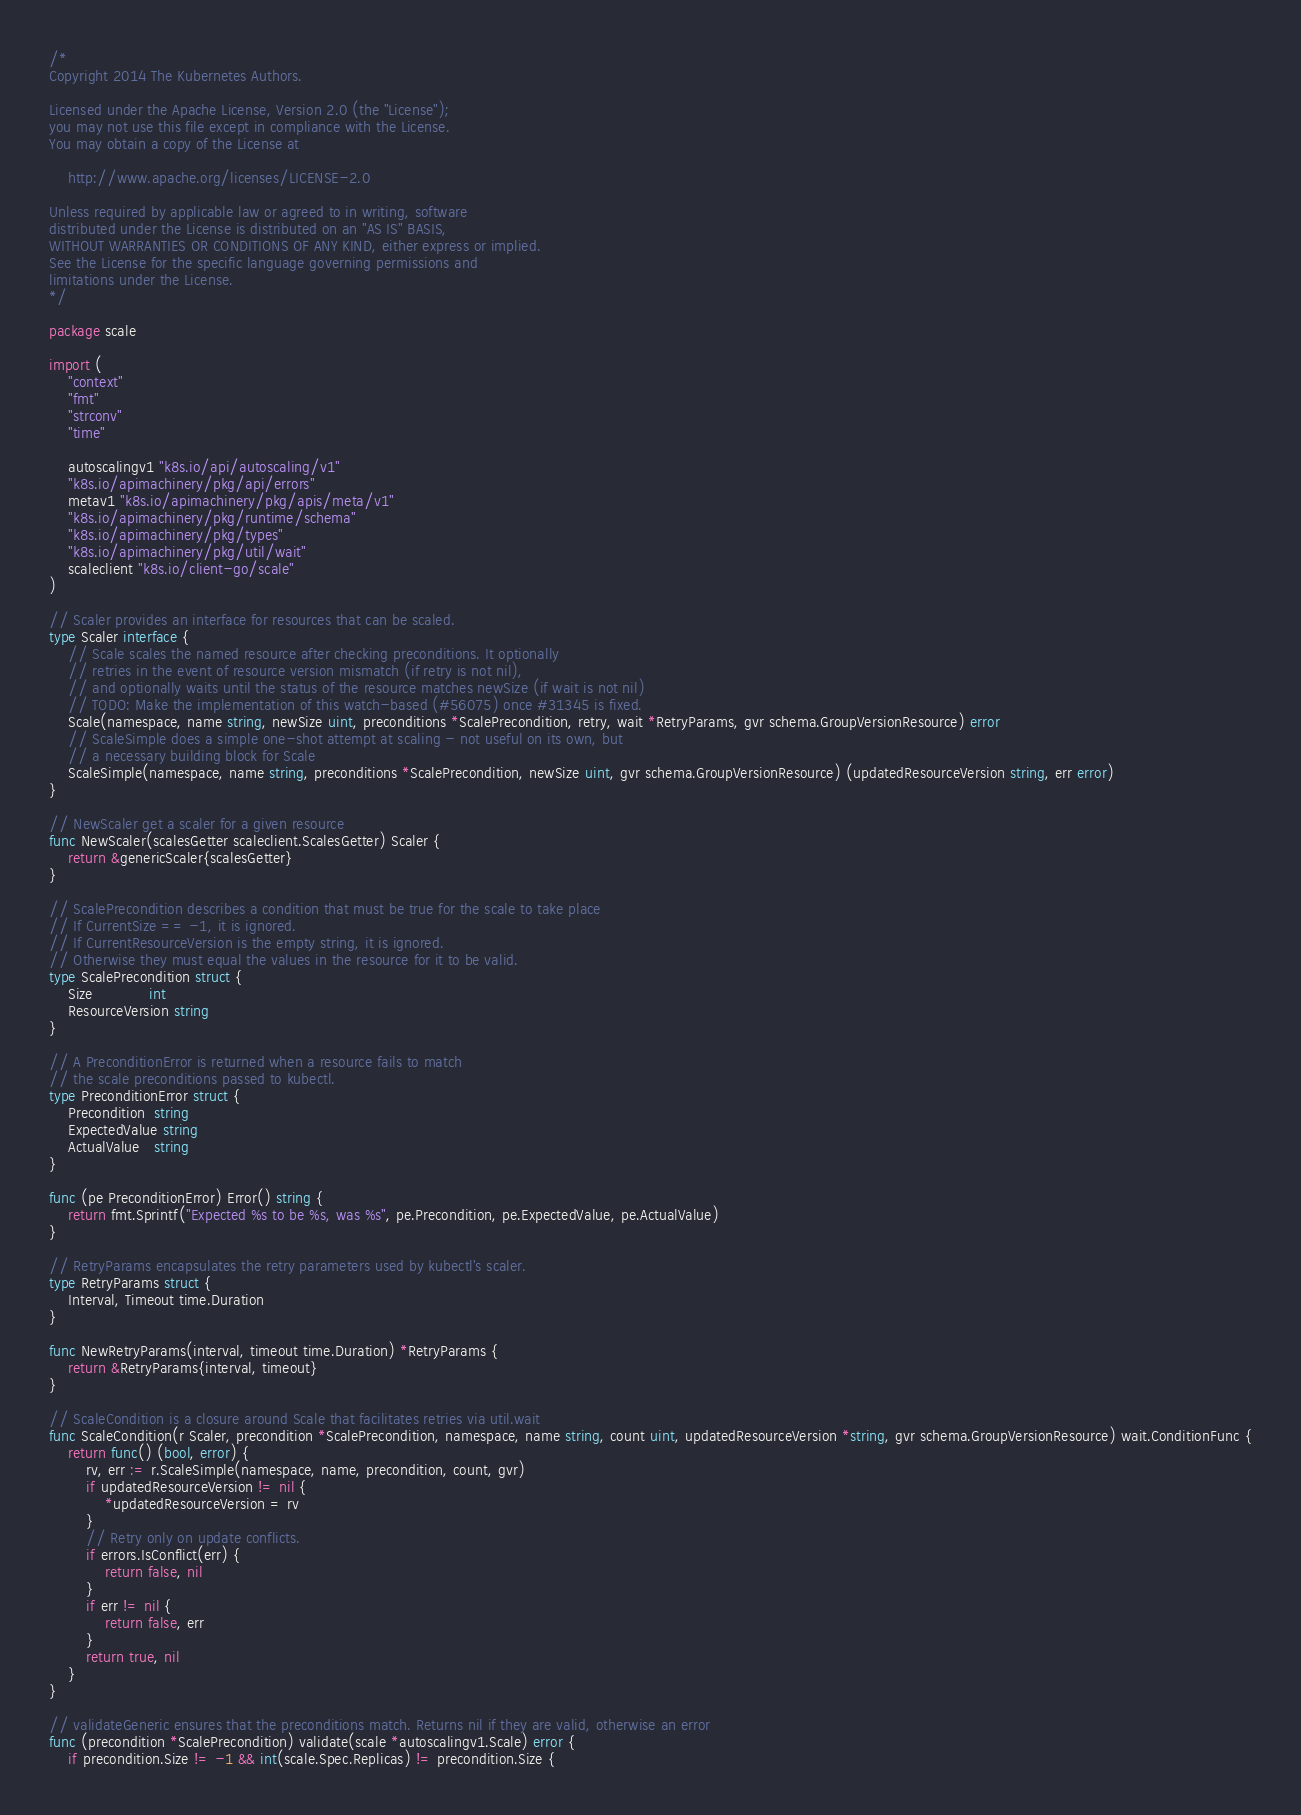Convert code to text. <code><loc_0><loc_0><loc_500><loc_500><_Go_>/*
Copyright 2014 The Kubernetes Authors.

Licensed under the Apache License, Version 2.0 (the "License");
you may not use this file except in compliance with the License.
You may obtain a copy of the License at

    http://www.apache.org/licenses/LICENSE-2.0

Unless required by applicable law or agreed to in writing, software
distributed under the License is distributed on an "AS IS" BASIS,
WITHOUT WARRANTIES OR CONDITIONS OF ANY KIND, either express or implied.
See the License for the specific language governing permissions and
limitations under the License.
*/

package scale

import (
	"context"
	"fmt"
	"strconv"
	"time"

	autoscalingv1 "k8s.io/api/autoscaling/v1"
	"k8s.io/apimachinery/pkg/api/errors"
	metav1 "k8s.io/apimachinery/pkg/apis/meta/v1"
	"k8s.io/apimachinery/pkg/runtime/schema"
	"k8s.io/apimachinery/pkg/types"
	"k8s.io/apimachinery/pkg/util/wait"
	scaleclient "k8s.io/client-go/scale"
)

// Scaler provides an interface for resources that can be scaled.
type Scaler interface {
	// Scale scales the named resource after checking preconditions. It optionally
	// retries in the event of resource version mismatch (if retry is not nil),
	// and optionally waits until the status of the resource matches newSize (if wait is not nil)
	// TODO: Make the implementation of this watch-based (#56075) once #31345 is fixed.
	Scale(namespace, name string, newSize uint, preconditions *ScalePrecondition, retry, wait *RetryParams, gvr schema.GroupVersionResource) error
	// ScaleSimple does a simple one-shot attempt at scaling - not useful on its own, but
	// a necessary building block for Scale
	ScaleSimple(namespace, name string, preconditions *ScalePrecondition, newSize uint, gvr schema.GroupVersionResource) (updatedResourceVersion string, err error)
}

// NewScaler get a scaler for a given resource
func NewScaler(scalesGetter scaleclient.ScalesGetter) Scaler {
	return &genericScaler{scalesGetter}
}

// ScalePrecondition describes a condition that must be true for the scale to take place
// If CurrentSize == -1, it is ignored.
// If CurrentResourceVersion is the empty string, it is ignored.
// Otherwise they must equal the values in the resource for it to be valid.
type ScalePrecondition struct {
	Size            int
	ResourceVersion string
}

// A PreconditionError is returned when a resource fails to match
// the scale preconditions passed to kubectl.
type PreconditionError struct {
	Precondition  string
	ExpectedValue string
	ActualValue   string
}

func (pe PreconditionError) Error() string {
	return fmt.Sprintf("Expected %s to be %s, was %s", pe.Precondition, pe.ExpectedValue, pe.ActualValue)
}

// RetryParams encapsulates the retry parameters used by kubectl's scaler.
type RetryParams struct {
	Interval, Timeout time.Duration
}

func NewRetryParams(interval, timeout time.Duration) *RetryParams {
	return &RetryParams{interval, timeout}
}

// ScaleCondition is a closure around Scale that facilitates retries via util.wait
func ScaleCondition(r Scaler, precondition *ScalePrecondition, namespace, name string, count uint, updatedResourceVersion *string, gvr schema.GroupVersionResource) wait.ConditionFunc {
	return func() (bool, error) {
		rv, err := r.ScaleSimple(namespace, name, precondition, count, gvr)
		if updatedResourceVersion != nil {
			*updatedResourceVersion = rv
		}
		// Retry only on update conflicts.
		if errors.IsConflict(err) {
			return false, nil
		}
		if err != nil {
			return false, err
		}
		return true, nil
	}
}

// validateGeneric ensures that the preconditions match. Returns nil if they are valid, otherwise an error
func (precondition *ScalePrecondition) validate(scale *autoscalingv1.Scale) error {
	if precondition.Size != -1 && int(scale.Spec.Replicas) != precondition.Size {</code> 